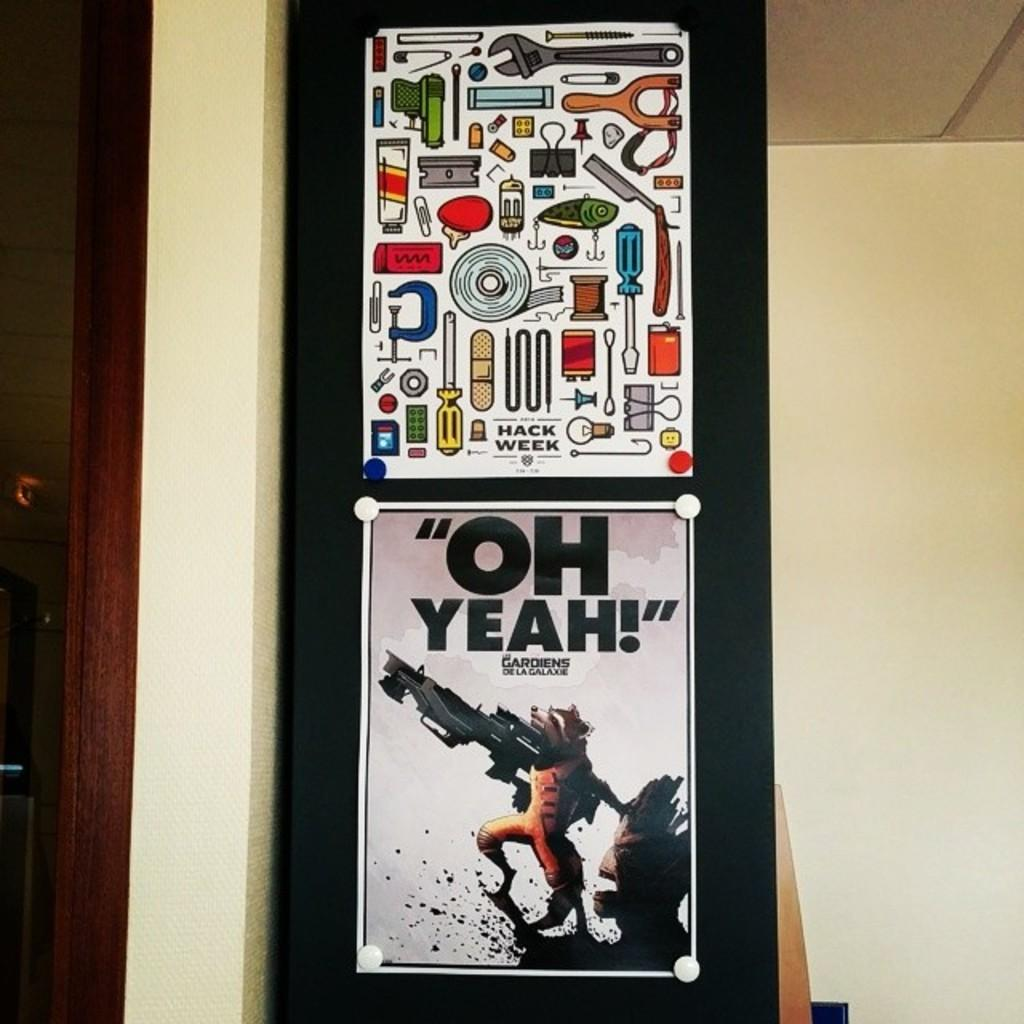<image>
Give a short and clear explanation of the subsequent image. A poster with cartoons of tools is hung above a poster with the raccoon from Guardians of the Galaxy. 